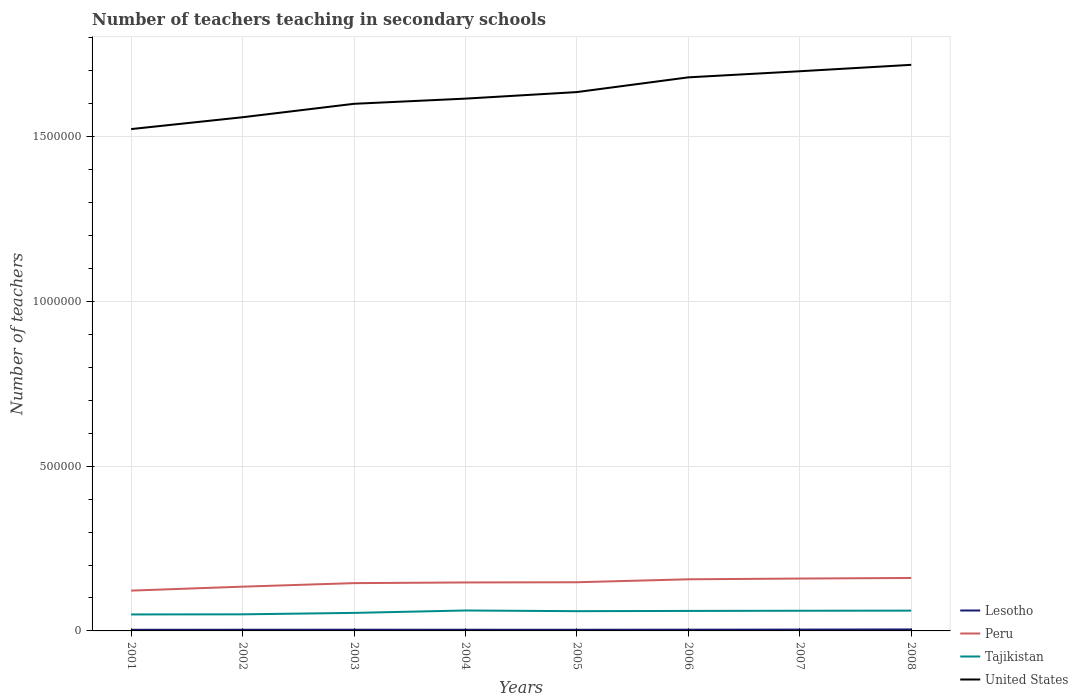How many different coloured lines are there?
Ensure brevity in your answer.  4. Is the number of lines equal to the number of legend labels?
Make the answer very short. Yes. Across all years, what is the maximum number of teachers teaching in secondary schools in Lesotho?
Make the answer very short. 3455. What is the total number of teachers teaching in secondary schools in United States in the graph?
Keep it short and to the point. -7.67e+04. What is the difference between the highest and the second highest number of teachers teaching in secondary schools in Lesotho?
Your response must be concise. 1062. How many years are there in the graph?
Provide a succinct answer. 8. Are the values on the major ticks of Y-axis written in scientific E-notation?
Your response must be concise. No. Does the graph contain any zero values?
Provide a succinct answer. No. Does the graph contain grids?
Provide a short and direct response. Yes. Where does the legend appear in the graph?
Provide a short and direct response. Bottom right. What is the title of the graph?
Your answer should be compact. Number of teachers teaching in secondary schools. What is the label or title of the Y-axis?
Give a very brief answer. Number of teachers. What is the Number of teachers of Lesotho in 2001?
Your answer should be compact. 3455. What is the Number of teachers of Peru in 2001?
Give a very brief answer. 1.22e+05. What is the Number of teachers in Tajikistan in 2001?
Give a very brief answer. 5.00e+04. What is the Number of teachers of United States in 2001?
Your answer should be very brief. 1.52e+06. What is the Number of teachers of Lesotho in 2002?
Offer a terse response. 3546. What is the Number of teachers of Peru in 2002?
Provide a short and direct response. 1.34e+05. What is the Number of teachers of Tajikistan in 2002?
Ensure brevity in your answer.  5.03e+04. What is the Number of teachers of United States in 2002?
Your response must be concise. 1.56e+06. What is the Number of teachers in Lesotho in 2003?
Your response must be concise. 3636. What is the Number of teachers in Peru in 2003?
Ensure brevity in your answer.  1.45e+05. What is the Number of teachers in Tajikistan in 2003?
Offer a very short reply. 5.47e+04. What is the Number of teachers in United States in 2003?
Give a very brief answer. 1.60e+06. What is the Number of teachers in Lesotho in 2004?
Ensure brevity in your answer.  3577. What is the Number of teachers of Peru in 2004?
Provide a succinct answer. 1.47e+05. What is the Number of teachers of Tajikistan in 2004?
Give a very brief answer. 6.20e+04. What is the Number of teachers in United States in 2004?
Make the answer very short. 1.62e+06. What is the Number of teachers of Lesotho in 2005?
Give a very brief answer. 3495. What is the Number of teachers in Peru in 2005?
Provide a short and direct response. 1.48e+05. What is the Number of teachers of Tajikistan in 2005?
Provide a succinct answer. 5.99e+04. What is the Number of teachers in United States in 2005?
Offer a terse response. 1.63e+06. What is the Number of teachers of Lesotho in 2006?
Offer a very short reply. 3725. What is the Number of teachers of Peru in 2006?
Offer a terse response. 1.57e+05. What is the Number of teachers of Tajikistan in 2006?
Ensure brevity in your answer.  6.07e+04. What is the Number of teachers of United States in 2006?
Make the answer very short. 1.68e+06. What is the Number of teachers of Lesotho in 2007?
Provide a succinct answer. 4006. What is the Number of teachers of Peru in 2007?
Provide a succinct answer. 1.59e+05. What is the Number of teachers in Tajikistan in 2007?
Ensure brevity in your answer.  6.12e+04. What is the Number of teachers of United States in 2007?
Your answer should be very brief. 1.70e+06. What is the Number of teachers of Lesotho in 2008?
Offer a very short reply. 4517. What is the Number of teachers in Peru in 2008?
Your answer should be very brief. 1.61e+05. What is the Number of teachers of Tajikistan in 2008?
Your answer should be compact. 6.16e+04. What is the Number of teachers of United States in 2008?
Your response must be concise. 1.72e+06. Across all years, what is the maximum Number of teachers of Lesotho?
Offer a very short reply. 4517. Across all years, what is the maximum Number of teachers in Peru?
Keep it short and to the point. 1.61e+05. Across all years, what is the maximum Number of teachers in Tajikistan?
Offer a terse response. 6.20e+04. Across all years, what is the maximum Number of teachers in United States?
Offer a very short reply. 1.72e+06. Across all years, what is the minimum Number of teachers of Lesotho?
Your response must be concise. 3455. Across all years, what is the minimum Number of teachers of Peru?
Give a very brief answer. 1.22e+05. Across all years, what is the minimum Number of teachers in Tajikistan?
Provide a short and direct response. 5.00e+04. Across all years, what is the minimum Number of teachers in United States?
Your answer should be very brief. 1.52e+06. What is the total Number of teachers in Lesotho in the graph?
Provide a short and direct response. 3.00e+04. What is the total Number of teachers of Peru in the graph?
Offer a very short reply. 1.17e+06. What is the total Number of teachers of Tajikistan in the graph?
Ensure brevity in your answer.  4.60e+05. What is the total Number of teachers of United States in the graph?
Give a very brief answer. 1.30e+07. What is the difference between the Number of teachers in Lesotho in 2001 and that in 2002?
Your answer should be compact. -91. What is the difference between the Number of teachers of Peru in 2001 and that in 2002?
Give a very brief answer. -1.20e+04. What is the difference between the Number of teachers in Tajikistan in 2001 and that in 2002?
Ensure brevity in your answer.  -311. What is the difference between the Number of teachers in United States in 2001 and that in 2002?
Provide a short and direct response. -3.59e+04. What is the difference between the Number of teachers of Lesotho in 2001 and that in 2003?
Your answer should be very brief. -181. What is the difference between the Number of teachers in Peru in 2001 and that in 2003?
Give a very brief answer. -2.27e+04. What is the difference between the Number of teachers of Tajikistan in 2001 and that in 2003?
Offer a very short reply. -4667. What is the difference between the Number of teachers in United States in 2001 and that in 2003?
Keep it short and to the point. -7.67e+04. What is the difference between the Number of teachers of Lesotho in 2001 and that in 2004?
Keep it short and to the point. -122. What is the difference between the Number of teachers of Peru in 2001 and that in 2004?
Keep it short and to the point. -2.47e+04. What is the difference between the Number of teachers of Tajikistan in 2001 and that in 2004?
Your response must be concise. -1.20e+04. What is the difference between the Number of teachers in United States in 2001 and that in 2004?
Make the answer very short. -9.24e+04. What is the difference between the Number of teachers of Peru in 2001 and that in 2005?
Make the answer very short. -2.53e+04. What is the difference between the Number of teachers of Tajikistan in 2001 and that in 2005?
Your answer should be compact. -9896. What is the difference between the Number of teachers in United States in 2001 and that in 2005?
Keep it short and to the point. -1.12e+05. What is the difference between the Number of teachers of Lesotho in 2001 and that in 2006?
Offer a very short reply. -270. What is the difference between the Number of teachers in Peru in 2001 and that in 2006?
Your answer should be compact. -3.43e+04. What is the difference between the Number of teachers of Tajikistan in 2001 and that in 2006?
Offer a very short reply. -1.07e+04. What is the difference between the Number of teachers in United States in 2001 and that in 2006?
Your answer should be very brief. -1.57e+05. What is the difference between the Number of teachers of Lesotho in 2001 and that in 2007?
Provide a short and direct response. -551. What is the difference between the Number of teachers of Peru in 2001 and that in 2007?
Ensure brevity in your answer.  -3.66e+04. What is the difference between the Number of teachers of Tajikistan in 2001 and that in 2007?
Your response must be concise. -1.12e+04. What is the difference between the Number of teachers of United States in 2001 and that in 2007?
Your answer should be compact. -1.75e+05. What is the difference between the Number of teachers in Lesotho in 2001 and that in 2008?
Your answer should be very brief. -1062. What is the difference between the Number of teachers in Peru in 2001 and that in 2008?
Make the answer very short. -3.84e+04. What is the difference between the Number of teachers of Tajikistan in 2001 and that in 2008?
Your answer should be very brief. -1.16e+04. What is the difference between the Number of teachers of United States in 2001 and that in 2008?
Provide a succinct answer. -1.95e+05. What is the difference between the Number of teachers of Lesotho in 2002 and that in 2003?
Your response must be concise. -90. What is the difference between the Number of teachers in Peru in 2002 and that in 2003?
Keep it short and to the point. -1.08e+04. What is the difference between the Number of teachers of Tajikistan in 2002 and that in 2003?
Your answer should be compact. -4356. What is the difference between the Number of teachers in United States in 2002 and that in 2003?
Your answer should be very brief. -4.08e+04. What is the difference between the Number of teachers of Lesotho in 2002 and that in 2004?
Provide a short and direct response. -31. What is the difference between the Number of teachers in Peru in 2002 and that in 2004?
Ensure brevity in your answer.  -1.28e+04. What is the difference between the Number of teachers in Tajikistan in 2002 and that in 2004?
Provide a succinct answer. -1.17e+04. What is the difference between the Number of teachers of United States in 2002 and that in 2004?
Make the answer very short. -5.65e+04. What is the difference between the Number of teachers of Peru in 2002 and that in 2005?
Give a very brief answer. -1.34e+04. What is the difference between the Number of teachers of Tajikistan in 2002 and that in 2005?
Offer a very short reply. -9585. What is the difference between the Number of teachers of United States in 2002 and that in 2005?
Offer a terse response. -7.64e+04. What is the difference between the Number of teachers of Lesotho in 2002 and that in 2006?
Provide a short and direct response. -179. What is the difference between the Number of teachers in Peru in 2002 and that in 2006?
Provide a short and direct response. -2.24e+04. What is the difference between the Number of teachers of Tajikistan in 2002 and that in 2006?
Your answer should be compact. -1.04e+04. What is the difference between the Number of teachers in United States in 2002 and that in 2006?
Your response must be concise. -1.21e+05. What is the difference between the Number of teachers of Lesotho in 2002 and that in 2007?
Your answer should be very brief. -460. What is the difference between the Number of teachers of Peru in 2002 and that in 2007?
Offer a very short reply. -2.46e+04. What is the difference between the Number of teachers in Tajikistan in 2002 and that in 2007?
Provide a short and direct response. -1.08e+04. What is the difference between the Number of teachers in United States in 2002 and that in 2007?
Your answer should be very brief. -1.40e+05. What is the difference between the Number of teachers of Lesotho in 2002 and that in 2008?
Your answer should be compact. -971. What is the difference between the Number of teachers of Peru in 2002 and that in 2008?
Offer a very short reply. -2.64e+04. What is the difference between the Number of teachers in Tajikistan in 2002 and that in 2008?
Provide a succinct answer. -1.12e+04. What is the difference between the Number of teachers in United States in 2002 and that in 2008?
Your response must be concise. -1.59e+05. What is the difference between the Number of teachers of Lesotho in 2003 and that in 2004?
Your answer should be compact. 59. What is the difference between the Number of teachers of Peru in 2003 and that in 2004?
Your answer should be compact. -2001. What is the difference between the Number of teachers in Tajikistan in 2003 and that in 2004?
Offer a very short reply. -7305. What is the difference between the Number of teachers in United States in 2003 and that in 2004?
Your answer should be compact. -1.57e+04. What is the difference between the Number of teachers of Lesotho in 2003 and that in 2005?
Keep it short and to the point. 141. What is the difference between the Number of teachers of Peru in 2003 and that in 2005?
Your response must be concise. -2622. What is the difference between the Number of teachers of Tajikistan in 2003 and that in 2005?
Ensure brevity in your answer.  -5229. What is the difference between the Number of teachers in United States in 2003 and that in 2005?
Give a very brief answer. -3.56e+04. What is the difference between the Number of teachers in Lesotho in 2003 and that in 2006?
Give a very brief answer. -89. What is the difference between the Number of teachers of Peru in 2003 and that in 2006?
Provide a short and direct response. -1.16e+04. What is the difference between the Number of teachers in Tajikistan in 2003 and that in 2006?
Make the answer very short. -5999. What is the difference between the Number of teachers in United States in 2003 and that in 2006?
Provide a short and direct response. -8.03e+04. What is the difference between the Number of teachers in Lesotho in 2003 and that in 2007?
Your answer should be compact. -370. What is the difference between the Number of teachers of Peru in 2003 and that in 2007?
Your answer should be very brief. -1.39e+04. What is the difference between the Number of teachers of Tajikistan in 2003 and that in 2007?
Your answer should be very brief. -6493. What is the difference between the Number of teachers of United States in 2003 and that in 2007?
Offer a very short reply. -9.88e+04. What is the difference between the Number of teachers in Lesotho in 2003 and that in 2008?
Ensure brevity in your answer.  -881. What is the difference between the Number of teachers of Peru in 2003 and that in 2008?
Make the answer very short. -1.56e+04. What is the difference between the Number of teachers of Tajikistan in 2003 and that in 2008?
Provide a short and direct response. -6892. What is the difference between the Number of teachers in United States in 2003 and that in 2008?
Offer a very short reply. -1.18e+05. What is the difference between the Number of teachers of Peru in 2004 and that in 2005?
Offer a very short reply. -621. What is the difference between the Number of teachers of Tajikistan in 2004 and that in 2005?
Make the answer very short. 2076. What is the difference between the Number of teachers in United States in 2004 and that in 2005?
Your answer should be compact. -1.99e+04. What is the difference between the Number of teachers in Lesotho in 2004 and that in 2006?
Keep it short and to the point. -148. What is the difference between the Number of teachers of Peru in 2004 and that in 2006?
Provide a succinct answer. -9615. What is the difference between the Number of teachers in Tajikistan in 2004 and that in 2006?
Provide a succinct answer. 1306. What is the difference between the Number of teachers of United States in 2004 and that in 2006?
Ensure brevity in your answer.  -6.45e+04. What is the difference between the Number of teachers of Lesotho in 2004 and that in 2007?
Offer a terse response. -429. What is the difference between the Number of teachers in Peru in 2004 and that in 2007?
Your response must be concise. -1.19e+04. What is the difference between the Number of teachers in Tajikistan in 2004 and that in 2007?
Your answer should be very brief. 812. What is the difference between the Number of teachers of United States in 2004 and that in 2007?
Provide a short and direct response. -8.31e+04. What is the difference between the Number of teachers in Lesotho in 2004 and that in 2008?
Your answer should be compact. -940. What is the difference between the Number of teachers of Peru in 2004 and that in 2008?
Provide a short and direct response. -1.36e+04. What is the difference between the Number of teachers of Tajikistan in 2004 and that in 2008?
Make the answer very short. 413. What is the difference between the Number of teachers in United States in 2004 and that in 2008?
Ensure brevity in your answer.  -1.03e+05. What is the difference between the Number of teachers of Lesotho in 2005 and that in 2006?
Your response must be concise. -230. What is the difference between the Number of teachers in Peru in 2005 and that in 2006?
Provide a succinct answer. -8994. What is the difference between the Number of teachers in Tajikistan in 2005 and that in 2006?
Offer a very short reply. -770. What is the difference between the Number of teachers in United States in 2005 and that in 2006?
Provide a short and direct response. -4.47e+04. What is the difference between the Number of teachers of Lesotho in 2005 and that in 2007?
Provide a short and direct response. -511. What is the difference between the Number of teachers of Peru in 2005 and that in 2007?
Your answer should be very brief. -1.12e+04. What is the difference between the Number of teachers in Tajikistan in 2005 and that in 2007?
Your answer should be compact. -1264. What is the difference between the Number of teachers in United States in 2005 and that in 2007?
Keep it short and to the point. -6.32e+04. What is the difference between the Number of teachers in Lesotho in 2005 and that in 2008?
Make the answer very short. -1022. What is the difference between the Number of teachers of Peru in 2005 and that in 2008?
Your answer should be very brief. -1.30e+04. What is the difference between the Number of teachers of Tajikistan in 2005 and that in 2008?
Ensure brevity in your answer.  -1663. What is the difference between the Number of teachers of United States in 2005 and that in 2008?
Keep it short and to the point. -8.27e+04. What is the difference between the Number of teachers in Lesotho in 2006 and that in 2007?
Keep it short and to the point. -281. What is the difference between the Number of teachers of Peru in 2006 and that in 2007?
Offer a terse response. -2242. What is the difference between the Number of teachers of Tajikistan in 2006 and that in 2007?
Your answer should be compact. -494. What is the difference between the Number of teachers of United States in 2006 and that in 2007?
Give a very brief answer. -1.85e+04. What is the difference between the Number of teachers in Lesotho in 2006 and that in 2008?
Offer a very short reply. -792. What is the difference between the Number of teachers of Peru in 2006 and that in 2008?
Your answer should be very brief. -4021. What is the difference between the Number of teachers of Tajikistan in 2006 and that in 2008?
Provide a succinct answer. -893. What is the difference between the Number of teachers of United States in 2006 and that in 2008?
Provide a succinct answer. -3.80e+04. What is the difference between the Number of teachers in Lesotho in 2007 and that in 2008?
Make the answer very short. -511. What is the difference between the Number of teachers in Peru in 2007 and that in 2008?
Keep it short and to the point. -1779. What is the difference between the Number of teachers in Tajikistan in 2007 and that in 2008?
Make the answer very short. -399. What is the difference between the Number of teachers in United States in 2007 and that in 2008?
Offer a terse response. -1.95e+04. What is the difference between the Number of teachers in Lesotho in 2001 and the Number of teachers in Peru in 2002?
Your response must be concise. -1.31e+05. What is the difference between the Number of teachers in Lesotho in 2001 and the Number of teachers in Tajikistan in 2002?
Keep it short and to the point. -4.69e+04. What is the difference between the Number of teachers in Lesotho in 2001 and the Number of teachers in United States in 2002?
Your answer should be very brief. -1.56e+06. What is the difference between the Number of teachers of Peru in 2001 and the Number of teachers of Tajikistan in 2002?
Keep it short and to the point. 7.20e+04. What is the difference between the Number of teachers in Peru in 2001 and the Number of teachers in United States in 2002?
Provide a succinct answer. -1.44e+06. What is the difference between the Number of teachers in Tajikistan in 2001 and the Number of teachers in United States in 2002?
Offer a very short reply. -1.51e+06. What is the difference between the Number of teachers of Lesotho in 2001 and the Number of teachers of Peru in 2003?
Your response must be concise. -1.42e+05. What is the difference between the Number of teachers of Lesotho in 2001 and the Number of teachers of Tajikistan in 2003?
Give a very brief answer. -5.12e+04. What is the difference between the Number of teachers in Lesotho in 2001 and the Number of teachers in United States in 2003?
Your answer should be very brief. -1.60e+06. What is the difference between the Number of teachers of Peru in 2001 and the Number of teachers of Tajikistan in 2003?
Give a very brief answer. 6.76e+04. What is the difference between the Number of teachers of Peru in 2001 and the Number of teachers of United States in 2003?
Your answer should be very brief. -1.48e+06. What is the difference between the Number of teachers in Tajikistan in 2001 and the Number of teachers in United States in 2003?
Make the answer very short. -1.55e+06. What is the difference between the Number of teachers of Lesotho in 2001 and the Number of teachers of Peru in 2004?
Keep it short and to the point. -1.44e+05. What is the difference between the Number of teachers in Lesotho in 2001 and the Number of teachers in Tajikistan in 2004?
Your response must be concise. -5.85e+04. What is the difference between the Number of teachers in Lesotho in 2001 and the Number of teachers in United States in 2004?
Keep it short and to the point. -1.61e+06. What is the difference between the Number of teachers in Peru in 2001 and the Number of teachers in Tajikistan in 2004?
Your answer should be compact. 6.03e+04. What is the difference between the Number of teachers in Peru in 2001 and the Number of teachers in United States in 2004?
Offer a very short reply. -1.49e+06. What is the difference between the Number of teachers in Tajikistan in 2001 and the Number of teachers in United States in 2004?
Your response must be concise. -1.57e+06. What is the difference between the Number of teachers of Lesotho in 2001 and the Number of teachers of Peru in 2005?
Offer a terse response. -1.44e+05. What is the difference between the Number of teachers in Lesotho in 2001 and the Number of teachers in Tajikistan in 2005?
Your answer should be compact. -5.65e+04. What is the difference between the Number of teachers of Lesotho in 2001 and the Number of teachers of United States in 2005?
Your response must be concise. -1.63e+06. What is the difference between the Number of teachers of Peru in 2001 and the Number of teachers of Tajikistan in 2005?
Keep it short and to the point. 6.24e+04. What is the difference between the Number of teachers of Peru in 2001 and the Number of teachers of United States in 2005?
Your answer should be very brief. -1.51e+06. What is the difference between the Number of teachers of Tajikistan in 2001 and the Number of teachers of United States in 2005?
Make the answer very short. -1.58e+06. What is the difference between the Number of teachers of Lesotho in 2001 and the Number of teachers of Peru in 2006?
Your answer should be very brief. -1.53e+05. What is the difference between the Number of teachers of Lesotho in 2001 and the Number of teachers of Tajikistan in 2006?
Provide a short and direct response. -5.72e+04. What is the difference between the Number of teachers in Lesotho in 2001 and the Number of teachers in United States in 2006?
Ensure brevity in your answer.  -1.68e+06. What is the difference between the Number of teachers in Peru in 2001 and the Number of teachers in Tajikistan in 2006?
Offer a very short reply. 6.16e+04. What is the difference between the Number of teachers in Peru in 2001 and the Number of teachers in United States in 2006?
Offer a very short reply. -1.56e+06. What is the difference between the Number of teachers of Tajikistan in 2001 and the Number of teachers of United States in 2006?
Your answer should be very brief. -1.63e+06. What is the difference between the Number of teachers of Lesotho in 2001 and the Number of teachers of Peru in 2007?
Offer a very short reply. -1.55e+05. What is the difference between the Number of teachers of Lesotho in 2001 and the Number of teachers of Tajikistan in 2007?
Provide a succinct answer. -5.77e+04. What is the difference between the Number of teachers of Lesotho in 2001 and the Number of teachers of United States in 2007?
Your response must be concise. -1.69e+06. What is the difference between the Number of teachers in Peru in 2001 and the Number of teachers in Tajikistan in 2007?
Ensure brevity in your answer.  6.11e+04. What is the difference between the Number of teachers in Peru in 2001 and the Number of teachers in United States in 2007?
Offer a terse response. -1.58e+06. What is the difference between the Number of teachers in Tajikistan in 2001 and the Number of teachers in United States in 2007?
Offer a terse response. -1.65e+06. What is the difference between the Number of teachers of Lesotho in 2001 and the Number of teachers of Peru in 2008?
Give a very brief answer. -1.57e+05. What is the difference between the Number of teachers of Lesotho in 2001 and the Number of teachers of Tajikistan in 2008?
Keep it short and to the point. -5.81e+04. What is the difference between the Number of teachers of Lesotho in 2001 and the Number of teachers of United States in 2008?
Offer a terse response. -1.71e+06. What is the difference between the Number of teachers in Peru in 2001 and the Number of teachers in Tajikistan in 2008?
Provide a short and direct response. 6.07e+04. What is the difference between the Number of teachers of Peru in 2001 and the Number of teachers of United States in 2008?
Your answer should be compact. -1.60e+06. What is the difference between the Number of teachers in Tajikistan in 2001 and the Number of teachers in United States in 2008?
Your answer should be very brief. -1.67e+06. What is the difference between the Number of teachers of Lesotho in 2002 and the Number of teachers of Peru in 2003?
Ensure brevity in your answer.  -1.41e+05. What is the difference between the Number of teachers of Lesotho in 2002 and the Number of teachers of Tajikistan in 2003?
Offer a very short reply. -5.11e+04. What is the difference between the Number of teachers of Lesotho in 2002 and the Number of teachers of United States in 2003?
Give a very brief answer. -1.60e+06. What is the difference between the Number of teachers in Peru in 2002 and the Number of teachers in Tajikistan in 2003?
Make the answer very short. 7.96e+04. What is the difference between the Number of teachers of Peru in 2002 and the Number of teachers of United States in 2003?
Provide a short and direct response. -1.47e+06. What is the difference between the Number of teachers in Tajikistan in 2002 and the Number of teachers in United States in 2003?
Ensure brevity in your answer.  -1.55e+06. What is the difference between the Number of teachers of Lesotho in 2002 and the Number of teachers of Peru in 2004?
Offer a terse response. -1.43e+05. What is the difference between the Number of teachers of Lesotho in 2002 and the Number of teachers of Tajikistan in 2004?
Keep it short and to the point. -5.85e+04. What is the difference between the Number of teachers of Lesotho in 2002 and the Number of teachers of United States in 2004?
Offer a very short reply. -1.61e+06. What is the difference between the Number of teachers of Peru in 2002 and the Number of teachers of Tajikistan in 2004?
Keep it short and to the point. 7.23e+04. What is the difference between the Number of teachers in Peru in 2002 and the Number of teachers in United States in 2004?
Provide a succinct answer. -1.48e+06. What is the difference between the Number of teachers in Tajikistan in 2002 and the Number of teachers in United States in 2004?
Ensure brevity in your answer.  -1.56e+06. What is the difference between the Number of teachers of Lesotho in 2002 and the Number of teachers of Peru in 2005?
Your answer should be compact. -1.44e+05. What is the difference between the Number of teachers in Lesotho in 2002 and the Number of teachers in Tajikistan in 2005?
Ensure brevity in your answer.  -5.64e+04. What is the difference between the Number of teachers in Lesotho in 2002 and the Number of teachers in United States in 2005?
Provide a short and direct response. -1.63e+06. What is the difference between the Number of teachers in Peru in 2002 and the Number of teachers in Tajikistan in 2005?
Give a very brief answer. 7.44e+04. What is the difference between the Number of teachers in Peru in 2002 and the Number of teachers in United States in 2005?
Your answer should be very brief. -1.50e+06. What is the difference between the Number of teachers of Tajikistan in 2002 and the Number of teachers of United States in 2005?
Ensure brevity in your answer.  -1.58e+06. What is the difference between the Number of teachers of Lesotho in 2002 and the Number of teachers of Peru in 2006?
Your answer should be compact. -1.53e+05. What is the difference between the Number of teachers of Lesotho in 2002 and the Number of teachers of Tajikistan in 2006?
Your answer should be very brief. -5.71e+04. What is the difference between the Number of teachers of Lesotho in 2002 and the Number of teachers of United States in 2006?
Keep it short and to the point. -1.68e+06. What is the difference between the Number of teachers of Peru in 2002 and the Number of teachers of Tajikistan in 2006?
Ensure brevity in your answer.  7.36e+04. What is the difference between the Number of teachers of Peru in 2002 and the Number of teachers of United States in 2006?
Offer a terse response. -1.55e+06. What is the difference between the Number of teachers of Tajikistan in 2002 and the Number of teachers of United States in 2006?
Your response must be concise. -1.63e+06. What is the difference between the Number of teachers in Lesotho in 2002 and the Number of teachers in Peru in 2007?
Provide a succinct answer. -1.55e+05. What is the difference between the Number of teachers in Lesotho in 2002 and the Number of teachers in Tajikistan in 2007?
Your answer should be very brief. -5.76e+04. What is the difference between the Number of teachers of Lesotho in 2002 and the Number of teachers of United States in 2007?
Make the answer very short. -1.69e+06. What is the difference between the Number of teachers of Peru in 2002 and the Number of teachers of Tajikistan in 2007?
Keep it short and to the point. 7.31e+04. What is the difference between the Number of teachers of Peru in 2002 and the Number of teachers of United States in 2007?
Provide a short and direct response. -1.56e+06. What is the difference between the Number of teachers of Tajikistan in 2002 and the Number of teachers of United States in 2007?
Ensure brevity in your answer.  -1.65e+06. What is the difference between the Number of teachers of Lesotho in 2002 and the Number of teachers of Peru in 2008?
Keep it short and to the point. -1.57e+05. What is the difference between the Number of teachers in Lesotho in 2002 and the Number of teachers in Tajikistan in 2008?
Keep it short and to the point. -5.80e+04. What is the difference between the Number of teachers of Lesotho in 2002 and the Number of teachers of United States in 2008?
Offer a very short reply. -1.71e+06. What is the difference between the Number of teachers in Peru in 2002 and the Number of teachers in Tajikistan in 2008?
Make the answer very short. 7.27e+04. What is the difference between the Number of teachers in Peru in 2002 and the Number of teachers in United States in 2008?
Provide a succinct answer. -1.58e+06. What is the difference between the Number of teachers in Tajikistan in 2002 and the Number of teachers in United States in 2008?
Make the answer very short. -1.67e+06. What is the difference between the Number of teachers of Lesotho in 2003 and the Number of teachers of Peru in 2004?
Keep it short and to the point. -1.43e+05. What is the difference between the Number of teachers of Lesotho in 2003 and the Number of teachers of Tajikistan in 2004?
Provide a succinct answer. -5.84e+04. What is the difference between the Number of teachers of Lesotho in 2003 and the Number of teachers of United States in 2004?
Your response must be concise. -1.61e+06. What is the difference between the Number of teachers of Peru in 2003 and the Number of teachers of Tajikistan in 2004?
Your answer should be compact. 8.30e+04. What is the difference between the Number of teachers in Peru in 2003 and the Number of teachers in United States in 2004?
Ensure brevity in your answer.  -1.47e+06. What is the difference between the Number of teachers of Tajikistan in 2003 and the Number of teachers of United States in 2004?
Offer a terse response. -1.56e+06. What is the difference between the Number of teachers in Lesotho in 2003 and the Number of teachers in Peru in 2005?
Your response must be concise. -1.44e+05. What is the difference between the Number of teachers in Lesotho in 2003 and the Number of teachers in Tajikistan in 2005?
Make the answer very short. -5.63e+04. What is the difference between the Number of teachers of Lesotho in 2003 and the Number of teachers of United States in 2005?
Ensure brevity in your answer.  -1.63e+06. What is the difference between the Number of teachers in Peru in 2003 and the Number of teachers in Tajikistan in 2005?
Your answer should be compact. 8.51e+04. What is the difference between the Number of teachers of Peru in 2003 and the Number of teachers of United States in 2005?
Provide a short and direct response. -1.49e+06. What is the difference between the Number of teachers of Tajikistan in 2003 and the Number of teachers of United States in 2005?
Provide a short and direct response. -1.58e+06. What is the difference between the Number of teachers of Lesotho in 2003 and the Number of teachers of Peru in 2006?
Make the answer very short. -1.53e+05. What is the difference between the Number of teachers of Lesotho in 2003 and the Number of teachers of Tajikistan in 2006?
Ensure brevity in your answer.  -5.71e+04. What is the difference between the Number of teachers of Lesotho in 2003 and the Number of teachers of United States in 2006?
Give a very brief answer. -1.68e+06. What is the difference between the Number of teachers in Peru in 2003 and the Number of teachers in Tajikistan in 2006?
Offer a very short reply. 8.43e+04. What is the difference between the Number of teachers in Peru in 2003 and the Number of teachers in United States in 2006?
Offer a very short reply. -1.53e+06. What is the difference between the Number of teachers of Tajikistan in 2003 and the Number of teachers of United States in 2006?
Your response must be concise. -1.62e+06. What is the difference between the Number of teachers of Lesotho in 2003 and the Number of teachers of Peru in 2007?
Offer a terse response. -1.55e+05. What is the difference between the Number of teachers of Lesotho in 2003 and the Number of teachers of Tajikistan in 2007?
Your answer should be compact. -5.76e+04. What is the difference between the Number of teachers in Lesotho in 2003 and the Number of teachers in United States in 2007?
Ensure brevity in your answer.  -1.69e+06. What is the difference between the Number of teachers of Peru in 2003 and the Number of teachers of Tajikistan in 2007?
Provide a succinct answer. 8.38e+04. What is the difference between the Number of teachers in Peru in 2003 and the Number of teachers in United States in 2007?
Offer a terse response. -1.55e+06. What is the difference between the Number of teachers in Tajikistan in 2003 and the Number of teachers in United States in 2007?
Give a very brief answer. -1.64e+06. What is the difference between the Number of teachers of Lesotho in 2003 and the Number of teachers of Peru in 2008?
Provide a short and direct response. -1.57e+05. What is the difference between the Number of teachers in Lesotho in 2003 and the Number of teachers in Tajikistan in 2008?
Your response must be concise. -5.79e+04. What is the difference between the Number of teachers of Lesotho in 2003 and the Number of teachers of United States in 2008?
Ensure brevity in your answer.  -1.71e+06. What is the difference between the Number of teachers of Peru in 2003 and the Number of teachers of Tajikistan in 2008?
Keep it short and to the point. 8.34e+04. What is the difference between the Number of teachers in Peru in 2003 and the Number of teachers in United States in 2008?
Your answer should be very brief. -1.57e+06. What is the difference between the Number of teachers of Tajikistan in 2003 and the Number of teachers of United States in 2008?
Keep it short and to the point. -1.66e+06. What is the difference between the Number of teachers of Lesotho in 2004 and the Number of teachers of Peru in 2005?
Offer a terse response. -1.44e+05. What is the difference between the Number of teachers in Lesotho in 2004 and the Number of teachers in Tajikistan in 2005?
Keep it short and to the point. -5.63e+04. What is the difference between the Number of teachers of Lesotho in 2004 and the Number of teachers of United States in 2005?
Provide a succinct answer. -1.63e+06. What is the difference between the Number of teachers in Peru in 2004 and the Number of teachers in Tajikistan in 2005?
Ensure brevity in your answer.  8.71e+04. What is the difference between the Number of teachers of Peru in 2004 and the Number of teachers of United States in 2005?
Ensure brevity in your answer.  -1.49e+06. What is the difference between the Number of teachers in Tajikistan in 2004 and the Number of teachers in United States in 2005?
Keep it short and to the point. -1.57e+06. What is the difference between the Number of teachers in Lesotho in 2004 and the Number of teachers in Peru in 2006?
Give a very brief answer. -1.53e+05. What is the difference between the Number of teachers in Lesotho in 2004 and the Number of teachers in Tajikistan in 2006?
Give a very brief answer. -5.71e+04. What is the difference between the Number of teachers of Lesotho in 2004 and the Number of teachers of United States in 2006?
Offer a terse response. -1.68e+06. What is the difference between the Number of teachers in Peru in 2004 and the Number of teachers in Tajikistan in 2006?
Offer a terse response. 8.63e+04. What is the difference between the Number of teachers in Peru in 2004 and the Number of teachers in United States in 2006?
Offer a terse response. -1.53e+06. What is the difference between the Number of teachers of Tajikistan in 2004 and the Number of teachers of United States in 2006?
Offer a terse response. -1.62e+06. What is the difference between the Number of teachers in Lesotho in 2004 and the Number of teachers in Peru in 2007?
Your answer should be very brief. -1.55e+05. What is the difference between the Number of teachers of Lesotho in 2004 and the Number of teachers of Tajikistan in 2007?
Your answer should be very brief. -5.76e+04. What is the difference between the Number of teachers in Lesotho in 2004 and the Number of teachers in United States in 2007?
Your answer should be compact. -1.69e+06. What is the difference between the Number of teachers of Peru in 2004 and the Number of teachers of Tajikistan in 2007?
Your response must be concise. 8.58e+04. What is the difference between the Number of teachers in Peru in 2004 and the Number of teachers in United States in 2007?
Your answer should be very brief. -1.55e+06. What is the difference between the Number of teachers of Tajikistan in 2004 and the Number of teachers of United States in 2007?
Provide a succinct answer. -1.64e+06. What is the difference between the Number of teachers in Lesotho in 2004 and the Number of teachers in Peru in 2008?
Keep it short and to the point. -1.57e+05. What is the difference between the Number of teachers in Lesotho in 2004 and the Number of teachers in Tajikistan in 2008?
Your answer should be very brief. -5.80e+04. What is the difference between the Number of teachers in Lesotho in 2004 and the Number of teachers in United States in 2008?
Your response must be concise. -1.71e+06. What is the difference between the Number of teachers in Peru in 2004 and the Number of teachers in Tajikistan in 2008?
Your answer should be compact. 8.54e+04. What is the difference between the Number of teachers of Peru in 2004 and the Number of teachers of United States in 2008?
Keep it short and to the point. -1.57e+06. What is the difference between the Number of teachers of Tajikistan in 2004 and the Number of teachers of United States in 2008?
Keep it short and to the point. -1.66e+06. What is the difference between the Number of teachers of Lesotho in 2005 and the Number of teachers of Peru in 2006?
Offer a terse response. -1.53e+05. What is the difference between the Number of teachers of Lesotho in 2005 and the Number of teachers of Tajikistan in 2006?
Your response must be concise. -5.72e+04. What is the difference between the Number of teachers in Lesotho in 2005 and the Number of teachers in United States in 2006?
Make the answer very short. -1.68e+06. What is the difference between the Number of teachers of Peru in 2005 and the Number of teachers of Tajikistan in 2006?
Keep it short and to the point. 8.70e+04. What is the difference between the Number of teachers of Peru in 2005 and the Number of teachers of United States in 2006?
Provide a succinct answer. -1.53e+06. What is the difference between the Number of teachers in Tajikistan in 2005 and the Number of teachers in United States in 2006?
Provide a succinct answer. -1.62e+06. What is the difference between the Number of teachers of Lesotho in 2005 and the Number of teachers of Peru in 2007?
Your answer should be very brief. -1.55e+05. What is the difference between the Number of teachers of Lesotho in 2005 and the Number of teachers of Tajikistan in 2007?
Offer a terse response. -5.77e+04. What is the difference between the Number of teachers of Lesotho in 2005 and the Number of teachers of United States in 2007?
Offer a very short reply. -1.69e+06. What is the difference between the Number of teachers in Peru in 2005 and the Number of teachers in Tajikistan in 2007?
Provide a short and direct response. 8.65e+04. What is the difference between the Number of teachers of Peru in 2005 and the Number of teachers of United States in 2007?
Provide a succinct answer. -1.55e+06. What is the difference between the Number of teachers in Tajikistan in 2005 and the Number of teachers in United States in 2007?
Your answer should be compact. -1.64e+06. What is the difference between the Number of teachers in Lesotho in 2005 and the Number of teachers in Peru in 2008?
Offer a very short reply. -1.57e+05. What is the difference between the Number of teachers of Lesotho in 2005 and the Number of teachers of Tajikistan in 2008?
Your response must be concise. -5.81e+04. What is the difference between the Number of teachers in Lesotho in 2005 and the Number of teachers in United States in 2008?
Offer a terse response. -1.71e+06. What is the difference between the Number of teachers of Peru in 2005 and the Number of teachers of Tajikistan in 2008?
Provide a succinct answer. 8.61e+04. What is the difference between the Number of teachers in Peru in 2005 and the Number of teachers in United States in 2008?
Give a very brief answer. -1.57e+06. What is the difference between the Number of teachers of Tajikistan in 2005 and the Number of teachers of United States in 2008?
Provide a succinct answer. -1.66e+06. What is the difference between the Number of teachers in Lesotho in 2006 and the Number of teachers in Peru in 2007?
Ensure brevity in your answer.  -1.55e+05. What is the difference between the Number of teachers in Lesotho in 2006 and the Number of teachers in Tajikistan in 2007?
Your answer should be compact. -5.75e+04. What is the difference between the Number of teachers of Lesotho in 2006 and the Number of teachers of United States in 2007?
Give a very brief answer. -1.69e+06. What is the difference between the Number of teachers in Peru in 2006 and the Number of teachers in Tajikistan in 2007?
Give a very brief answer. 9.55e+04. What is the difference between the Number of teachers in Peru in 2006 and the Number of teachers in United States in 2007?
Your answer should be very brief. -1.54e+06. What is the difference between the Number of teachers of Tajikistan in 2006 and the Number of teachers of United States in 2007?
Your response must be concise. -1.64e+06. What is the difference between the Number of teachers of Lesotho in 2006 and the Number of teachers of Peru in 2008?
Your answer should be compact. -1.57e+05. What is the difference between the Number of teachers in Lesotho in 2006 and the Number of teachers in Tajikistan in 2008?
Your answer should be compact. -5.79e+04. What is the difference between the Number of teachers of Lesotho in 2006 and the Number of teachers of United States in 2008?
Offer a very short reply. -1.71e+06. What is the difference between the Number of teachers in Peru in 2006 and the Number of teachers in Tajikistan in 2008?
Keep it short and to the point. 9.51e+04. What is the difference between the Number of teachers of Peru in 2006 and the Number of teachers of United States in 2008?
Keep it short and to the point. -1.56e+06. What is the difference between the Number of teachers of Tajikistan in 2006 and the Number of teachers of United States in 2008?
Your response must be concise. -1.66e+06. What is the difference between the Number of teachers in Lesotho in 2007 and the Number of teachers in Peru in 2008?
Provide a short and direct response. -1.57e+05. What is the difference between the Number of teachers of Lesotho in 2007 and the Number of teachers of Tajikistan in 2008?
Keep it short and to the point. -5.76e+04. What is the difference between the Number of teachers in Lesotho in 2007 and the Number of teachers in United States in 2008?
Your answer should be compact. -1.71e+06. What is the difference between the Number of teachers in Peru in 2007 and the Number of teachers in Tajikistan in 2008?
Ensure brevity in your answer.  9.73e+04. What is the difference between the Number of teachers of Peru in 2007 and the Number of teachers of United States in 2008?
Provide a succinct answer. -1.56e+06. What is the difference between the Number of teachers in Tajikistan in 2007 and the Number of teachers in United States in 2008?
Make the answer very short. -1.66e+06. What is the average Number of teachers of Lesotho per year?
Give a very brief answer. 3744.62. What is the average Number of teachers in Peru per year?
Offer a very short reply. 1.47e+05. What is the average Number of teachers in Tajikistan per year?
Make the answer very short. 5.76e+04. What is the average Number of teachers of United States per year?
Offer a very short reply. 1.63e+06. In the year 2001, what is the difference between the Number of teachers of Lesotho and Number of teachers of Peru?
Make the answer very short. -1.19e+05. In the year 2001, what is the difference between the Number of teachers of Lesotho and Number of teachers of Tajikistan?
Your answer should be very brief. -4.66e+04. In the year 2001, what is the difference between the Number of teachers in Lesotho and Number of teachers in United States?
Ensure brevity in your answer.  -1.52e+06. In the year 2001, what is the difference between the Number of teachers in Peru and Number of teachers in Tajikistan?
Provide a short and direct response. 7.23e+04. In the year 2001, what is the difference between the Number of teachers in Peru and Number of teachers in United States?
Offer a terse response. -1.40e+06. In the year 2001, what is the difference between the Number of teachers in Tajikistan and Number of teachers in United States?
Ensure brevity in your answer.  -1.47e+06. In the year 2002, what is the difference between the Number of teachers in Lesotho and Number of teachers in Peru?
Offer a terse response. -1.31e+05. In the year 2002, what is the difference between the Number of teachers of Lesotho and Number of teachers of Tajikistan?
Provide a short and direct response. -4.68e+04. In the year 2002, what is the difference between the Number of teachers in Lesotho and Number of teachers in United States?
Keep it short and to the point. -1.55e+06. In the year 2002, what is the difference between the Number of teachers in Peru and Number of teachers in Tajikistan?
Provide a succinct answer. 8.39e+04. In the year 2002, what is the difference between the Number of teachers of Peru and Number of teachers of United States?
Make the answer very short. -1.42e+06. In the year 2002, what is the difference between the Number of teachers of Tajikistan and Number of teachers of United States?
Your answer should be compact. -1.51e+06. In the year 2003, what is the difference between the Number of teachers of Lesotho and Number of teachers of Peru?
Ensure brevity in your answer.  -1.41e+05. In the year 2003, what is the difference between the Number of teachers in Lesotho and Number of teachers in Tajikistan?
Offer a very short reply. -5.11e+04. In the year 2003, what is the difference between the Number of teachers of Lesotho and Number of teachers of United States?
Ensure brevity in your answer.  -1.60e+06. In the year 2003, what is the difference between the Number of teachers in Peru and Number of teachers in Tajikistan?
Offer a very short reply. 9.03e+04. In the year 2003, what is the difference between the Number of teachers in Peru and Number of teachers in United States?
Provide a succinct answer. -1.45e+06. In the year 2003, what is the difference between the Number of teachers of Tajikistan and Number of teachers of United States?
Offer a terse response. -1.54e+06. In the year 2004, what is the difference between the Number of teachers in Lesotho and Number of teachers in Peru?
Your answer should be very brief. -1.43e+05. In the year 2004, what is the difference between the Number of teachers in Lesotho and Number of teachers in Tajikistan?
Offer a terse response. -5.84e+04. In the year 2004, what is the difference between the Number of teachers of Lesotho and Number of teachers of United States?
Keep it short and to the point. -1.61e+06. In the year 2004, what is the difference between the Number of teachers of Peru and Number of teachers of Tajikistan?
Provide a short and direct response. 8.50e+04. In the year 2004, what is the difference between the Number of teachers of Peru and Number of teachers of United States?
Your answer should be compact. -1.47e+06. In the year 2004, what is the difference between the Number of teachers of Tajikistan and Number of teachers of United States?
Your answer should be very brief. -1.55e+06. In the year 2005, what is the difference between the Number of teachers of Lesotho and Number of teachers of Peru?
Your answer should be compact. -1.44e+05. In the year 2005, what is the difference between the Number of teachers in Lesotho and Number of teachers in Tajikistan?
Your answer should be compact. -5.64e+04. In the year 2005, what is the difference between the Number of teachers in Lesotho and Number of teachers in United States?
Offer a terse response. -1.63e+06. In the year 2005, what is the difference between the Number of teachers in Peru and Number of teachers in Tajikistan?
Ensure brevity in your answer.  8.77e+04. In the year 2005, what is the difference between the Number of teachers of Peru and Number of teachers of United States?
Provide a short and direct response. -1.49e+06. In the year 2005, what is the difference between the Number of teachers in Tajikistan and Number of teachers in United States?
Offer a very short reply. -1.57e+06. In the year 2006, what is the difference between the Number of teachers of Lesotho and Number of teachers of Peru?
Ensure brevity in your answer.  -1.53e+05. In the year 2006, what is the difference between the Number of teachers of Lesotho and Number of teachers of Tajikistan?
Your answer should be very brief. -5.70e+04. In the year 2006, what is the difference between the Number of teachers of Lesotho and Number of teachers of United States?
Give a very brief answer. -1.68e+06. In the year 2006, what is the difference between the Number of teachers in Peru and Number of teachers in Tajikistan?
Offer a very short reply. 9.60e+04. In the year 2006, what is the difference between the Number of teachers of Peru and Number of teachers of United States?
Keep it short and to the point. -1.52e+06. In the year 2006, what is the difference between the Number of teachers in Tajikistan and Number of teachers in United States?
Provide a short and direct response. -1.62e+06. In the year 2007, what is the difference between the Number of teachers in Lesotho and Number of teachers in Peru?
Provide a short and direct response. -1.55e+05. In the year 2007, what is the difference between the Number of teachers in Lesotho and Number of teachers in Tajikistan?
Provide a succinct answer. -5.72e+04. In the year 2007, what is the difference between the Number of teachers in Lesotho and Number of teachers in United States?
Your answer should be compact. -1.69e+06. In the year 2007, what is the difference between the Number of teachers in Peru and Number of teachers in Tajikistan?
Your answer should be compact. 9.77e+04. In the year 2007, what is the difference between the Number of teachers in Peru and Number of teachers in United States?
Keep it short and to the point. -1.54e+06. In the year 2007, what is the difference between the Number of teachers of Tajikistan and Number of teachers of United States?
Offer a terse response. -1.64e+06. In the year 2008, what is the difference between the Number of teachers of Lesotho and Number of teachers of Peru?
Give a very brief answer. -1.56e+05. In the year 2008, what is the difference between the Number of teachers of Lesotho and Number of teachers of Tajikistan?
Offer a terse response. -5.71e+04. In the year 2008, what is the difference between the Number of teachers of Lesotho and Number of teachers of United States?
Provide a short and direct response. -1.71e+06. In the year 2008, what is the difference between the Number of teachers of Peru and Number of teachers of Tajikistan?
Your answer should be compact. 9.91e+04. In the year 2008, what is the difference between the Number of teachers of Peru and Number of teachers of United States?
Keep it short and to the point. -1.56e+06. In the year 2008, what is the difference between the Number of teachers of Tajikistan and Number of teachers of United States?
Your response must be concise. -1.66e+06. What is the ratio of the Number of teachers of Lesotho in 2001 to that in 2002?
Offer a very short reply. 0.97. What is the ratio of the Number of teachers in Peru in 2001 to that in 2002?
Your answer should be very brief. 0.91. What is the ratio of the Number of teachers in United States in 2001 to that in 2002?
Ensure brevity in your answer.  0.98. What is the ratio of the Number of teachers in Lesotho in 2001 to that in 2003?
Provide a short and direct response. 0.95. What is the ratio of the Number of teachers of Peru in 2001 to that in 2003?
Your answer should be compact. 0.84. What is the ratio of the Number of teachers of Tajikistan in 2001 to that in 2003?
Make the answer very short. 0.91. What is the ratio of the Number of teachers of United States in 2001 to that in 2003?
Your response must be concise. 0.95. What is the ratio of the Number of teachers of Lesotho in 2001 to that in 2004?
Keep it short and to the point. 0.97. What is the ratio of the Number of teachers of Peru in 2001 to that in 2004?
Your answer should be very brief. 0.83. What is the ratio of the Number of teachers in Tajikistan in 2001 to that in 2004?
Provide a short and direct response. 0.81. What is the ratio of the Number of teachers of United States in 2001 to that in 2004?
Offer a terse response. 0.94. What is the ratio of the Number of teachers of Peru in 2001 to that in 2005?
Make the answer very short. 0.83. What is the ratio of the Number of teachers in Tajikistan in 2001 to that in 2005?
Ensure brevity in your answer.  0.83. What is the ratio of the Number of teachers in United States in 2001 to that in 2005?
Provide a short and direct response. 0.93. What is the ratio of the Number of teachers of Lesotho in 2001 to that in 2006?
Ensure brevity in your answer.  0.93. What is the ratio of the Number of teachers in Peru in 2001 to that in 2006?
Your answer should be very brief. 0.78. What is the ratio of the Number of teachers in Tajikistan in 2001 to that in 2006?
Ensure brevity in your answer.  0.82. What is the ratio of the Number of teachers of United States in 2001 to that in 2006?
Your response must be concise. 0.91. What is the ratio of the Number of teachers in Lesotho in 2001 to that in 2007?
Offer a very short reply. 0.86. What is the ratio of the Number of teachers of Peru in 2001 to that in 2007?
Your answer should be compact. 0.77. What is the ratio of the Number of teachers of Tajikistan in 2001 to that in 2007?
Keep it short and to the point. 0.82. What is the ratio of the Number of teachers of United States in 2001 to that in 2007?
Your response must be concise. 0.9. What is the ratio of the Number of teachers in Lesotho in 2001 to that in 2008?
Ensure brevity in your answer.  0.76. What is the ratio of the Number of teachers of Peru in 2001 to that in 2008?
Offer a very short reply. 0.76. What is the ratio of the Number of teachers in Tajikistan in 2001 to that in 2008?
Give a very brief answer. 0.81. What is the ratio of the Number of teachers in United States in 2001 to that in 2008?
Offer a very short reply. 0.89. What is the ratio of the Number of teachers in Lesotho in 2002 to that in 2003?
Offer a very short reply. 0.98. What is the ratio of the Number of teachers in Peru in 2002 to that in 2003?
Your answer should be very brief. 0.93. What is the ratio of the Number of teachers of Tajikistan in 2002 to that in 2003?
Keep it short and to the point. 0.92. What is the ratio of the Number of teachers in United States in 2002 to that in 2003?
Your answer should be very brief. 0.97. What is the ratio of the Number of teachers in Lesotho in 2002 to that in 2004?
Provide a succinct answer. 0.99. What is the ratio of the Number of teachers in Peru in 2002 to that in 2004?
Ensure brevity in your answer.  0.91. What is the ratio of the Number of teachers in Tajikistan in 2002 to that in 2004?
Give a very brief answer. 0.81. What is the ratio of the Number of teachers of United States in 2002 to that in 2004?
Give a very brief answer. 0.96. What is the ratio of the Number of teachers in Lesotho in 2002 to that in 2005?
Your answer should be very brief. 1.01. What is the ratio of the Number of teachers of Peru in 2002 to that in 2005?
Keep it short and to the point. 0.91. What is the ratio of the Number of teachers in Tajikistan in 2002 to that in 2005?
Ensure brevity in your answer.  0.84. What is the ratio of the Number of teachers in United States in 2002 to that in 2005?
Your answer should be compact. 0.95. What is the ratio of the Number of teachers in Lesotho in 2002 to that in 2006?
Your answer should be compact. 0.95. What is the ratio of the Number of teachers of Peru in 2002 to that in 2006?
Keep it short and to the point. 0.86. What is the ratio of the Number of teachers in Tajikistan in 2002 to that in 2006?
Make the answer very short. 0.83. What is the ratio of the Number of teachers of United States in 2002 to that in 2006?
Offer a terse response. 0.93. What is the ratio of the Number of teachers in Lesotho in 2002 to that in 2007?
Give a very brief answer. 0.89. What is the ratio of the Number of teachers of Peru in 2002 to that in 2007?
Make the answer very short. 0.85. What is the ratio of the Number of teachers in Tajikistan in 2002 to that in 2007?
Your answer should be very brief. 0.82. What is the ratio of the Number of teachers in United States in 2002 to that in 2007?
Your response must be concise. 0.92. What is the ratio of the Number of teachers in Lesotho in 2002 to that in 2008?
Your answer should be compact. 0.79. What is the ratio of the Number of teachers of Peru in 2002 to that in 2008?
Your answer should be very brief. 0.84. What is the ratio of the Number of teachers of Tajikistan in 2002 to that in 2008?
Keep it short and to the point. 0.82. What is the ratio of the Number of teachers in United States in 2002 to that in 2008?
Make the answer very short. 0.91. What is the ratio of the Number of teachers of Lesotho in 2003 to that in 2004?
Keep it short and to the point. 1.02. What is the ratio of the Number of teachers of Peru in 2003 to that in 2004?
Offer a very short reply. 0.99. What is the ratio of the Number of teachers in Tajikistan in 2003 to that in 2004?
Your answer should be very brief. 0.88. What is the ratio of the Number of teachers of United States in 2003 to that in 2004?
Provide a short and direct response. 0.99. What is the ratio of the Number of teachers of Lesotho in 2003 to that in 2005?
Provide a succinct answer. 1.04. What is the ratio of the Number of teachers in Peru in 2003 to that in 2005?
Ensure brevity in your answer.  0.98. What is the ratio of the Number of teachers in Tajikistan in 2003 to that in 2005?
Your response must be concise. 0.91. What is the ratio of the Number of teachers of United States in 2003 to that in 2005?
Offer a terse response. 0.98. What is the ratio of the Number of teachers of Lesotho in 2003 to that in 2006?
Provide a succinct answer. 0.98. What is the ratio of the Number of teachers of Peru in 2003 to that in 2006?
Your answer should be very brief. 0.93. What is the ratio of the Number of teachers of Tajikistan in 2003 to that in 2006?
Give a very brief answer. 0.9. What is the ratio of the Number of teachers in United States in 2003 to that in 2006?
Your answer should be compact. 0.95. What is the ratio of the Number of teachers of Lesotho in 2003 to that in 2007?
Your answer should be very brief. 0.91. What is the ratio of the Number of teachers of Peru in 2003 to that in 2007?
Your answer should be compact. 0.91. What is the ratio of the Number of teachers in Tajikistan in 2003 to that in 2007?
Give a very brief answer. 0.89. What is the ratio of the Number of teachers in United States in 2003 to that in 2007?
Provide a short and direct response. 0.94. What is the ratio of the Number of teachers in Lesotho in 2003 to that in 2008?
Give a very brief answer. 0.81. What is the ratio of the Number of teachers in Peru in 2003 to that in 2008?
Make the answer very short. 0.9. What is the ratio of the Number of teachers in Tajikistan in 2003 to that in 2008?
Provide a succinct answer. 0.89. What is the ratio of the Number of teachers of United States in 2003 to that in 2008?
Offer a very short reply. 0.93. What is the ratio of the Number of teachers in Lesotho in 2004 to that in 2005?
Offer a very short reply. 1.02. What is the ratio of the Number of teachers in Tajikistan in 2004 to that in 2005?
Your answer should be compact. 1.03. What is the ratio of the Number of teachers in United States in 2004 to that in 2005?
Your answer should be very brief. 0.99. What is the ratio of the Number of teachers in Lesotho in 2004 to that in 2006?
Make the answer very short. 0.96. What is the ratio of the Number of teachers in Peru in 2004 to that in 2006?
Keep it short and to the point. 0.94. What is the ratio of the Number of teachers in Tajikistan in 2004 to that in 2006?
Make the answer very short. 1.02. What is the ratio of the Number of teachers of United States in 2004 to that in 2006?
Give a very brief answer. 0.96. What is the ratio of the Number of teachers in Lesotho in 2004 to that in 2007?
Your answer should be very brief. 0.89. What is the ratio of the Number of teachers of Peru in 2004 to that in 2007?
Keep it short and to the point. 0.93. What is the ratio of the Number of teachers of Tajikistan in 2004 to that in 2007?
Ensure brevity in your answer.  1.01. What is the ratio of the Number of teachers of United States in 2004 to that in 2007?
Keep it short and to the point. 0.95. What is the ratio of the Number of teachers in Lesotho in 2004 to that in 2008?
Offer a very short reply. 0.79. What is the ratio of the Number of teachers in Peru in 2004 to that in 2008?
Your answer should be very brief. 0.92. What is the ratio of the Number of teachers of Tajikistan in 2004 to that in 2008?
Offer a very short reply. 1.01. What is the ratio of the Number of teachers of United States in 2004 to that in 2008?
Your answer should be very brief. 0.94. What is the ratio of the Number of teachers in Lesotho in 2005 to that in 2006?
Keep it short and to the point. 0.94. What is the ratio of the Number of teachers in Peru in 2005 to that in 2006?
Your response must be concise. 0.94. What is the ratio of the Number of teachers of Tajikistan in 2005 to that in 2006?
Offer a terse response. 0.99. What is the ratio of the Number of teachers in United States in 2005 to that in 2006?
Give a very brief answer. 0.97. What is the ratio of the Number of teachers in Lesotho in 2005 to that in 2007?
Your response must be concise. 0.87. What is the ratio of the Number of teachers of Peru in 2005 to that in 2007?
Offer a very short reply. 0.93. What is the ratio of the Number of teachers in Tajikistan in 2005 to that in 2007?
Provide a succinct answer. 0.98. What is the ratio of the Number of teachers in United States in 2005 to that in 2007?
Provide a succinct answer. 0.96. What is the ratio of the Number of teachers of Lesotho in 2005 to that in 2008?
Provide a short and direct response. 0.77. What is the ratio of the Number of teachers of Peru in 2005 to that in 2008?
Provide a succinct answer. 0.92. What is the ratio of the Number of teachers of United States in 2005 to that in 2008?
Give a very brief answer. 0.95. What is the ratio of the Number of teachers of Lesotho in 2006 to that in 2007?
Your answer should be very brief. 0.93. What is the ratio of the Number of teachers in Peru in 2006 to that in 2007?
Your answer should be compact. 0.99. What is the ratio of the Number of teachers in Tajikistan in 2006 to that in 2007?
Provide a succinct answer. 0.99. What is the ratio of the Number of teachers of United States in 2006 to that in 2007?
Ensure brevity in your answer.  0.99. What is the ratio of the Number of teachers in Lesotho in 2006 to that in 2008?
Ensure brevity in your answer.  0.82. What is the ratio of the Number of teachers of Tajikistan in 2006 to that in 2008?
Ensure brevity in your answer.  0.99. What is the ratio of the Number of teachers in United States in 2006 to that in 2008?
Offer a terse response. 0.98. What is the ratio of the Number of teachers of Lesotho in 2007 to that in 2008?
Offer a very short reply. 0.89. What is the ratio of the Number of teachers of Peru in 2007 to that in 2008?
Your answer should be very brief. 0.99. What is the ratio of the Number of teachers in Tajikistan in 2007 to that in 2008?
Provide a succinct answer. 0.99. What is the ratio of the Number of teachers of United States in 2007 to that in 2008?
Make the answer very short. 0.99. What is the difference between the highest and the second highest Number of teachers in Lesotho?
Offer a very short reply. 511. What is the difference between the highest and the second highest Number of teachers of Peru?
Make the answer very short. 1779. What is the difference between the highest and the second highest Number of teachers of Tajikistan?
Your answer should be very brief. 413. What is the difference between the highest and the second highest Number of teachers of United States?
Ensure brevity in your answer.  1.95e+04. What is the difference between the highest and the lowest Number of teachers of Lesotho?
Keep it short and to the point. 1062. What is the difference between the highest and the lowest Number of teachers of Peru?
Provide a succinct answer. 3.84e+04. What is the difference between the highest and the lowest Number of teachers of Tajikistan?
Give a very brief answer. 1.20e+04. What is the difference between the highest and the lowest Number of teachers of United States?
Your answer should be very brief. 1.95e+05. 